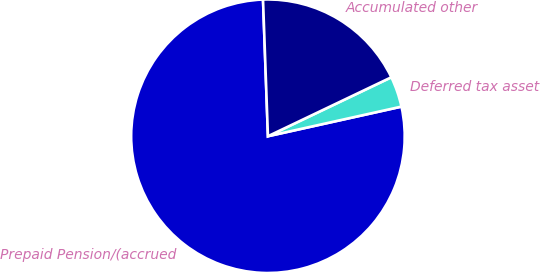Convert chart. <chart><loc_0><loc_0><loc_500><loc_500><pie_chart><fcel>Prepaid Pension/(accrued<fcel>Deferred tax asset<fcel>Accumulated other<nl><fcel>77.91%<fcel>3.62%<fcel>18.48%<nl></chart> 